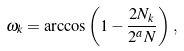<formula> <loc_0><loc_0><loc_500><loc_500>\omega _ { k } = \arccos \left ( 1 - \frac { 2 N _ { k } } { 2 ^ { a } N } \right ) \, ,</formula> 